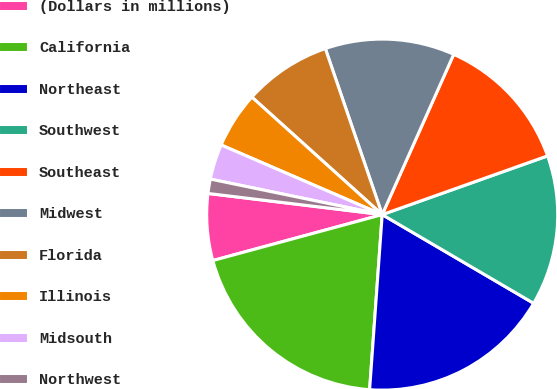Convert chart. <chart><loc_0><loc_0><loc_500><loc_500><pie_chart><fcel>(Dollars in millions)<fcel>California<fcel>Northeast<fcel>Southwest<fcel>Southeast<fcel>Midwest<fcel>Florida<fcel>Illinois<fcel>Midsouth<fcel>Northwest<nl><fcel>6.14%<fcel>19.64%<fcel>17.71%<fcel>13.86%<fcel>12.89%<fcel>11.93%<fcel>8.07%<fcel>5.18%<fcel>3.25%<fcel>1.32%<nl></chart> 